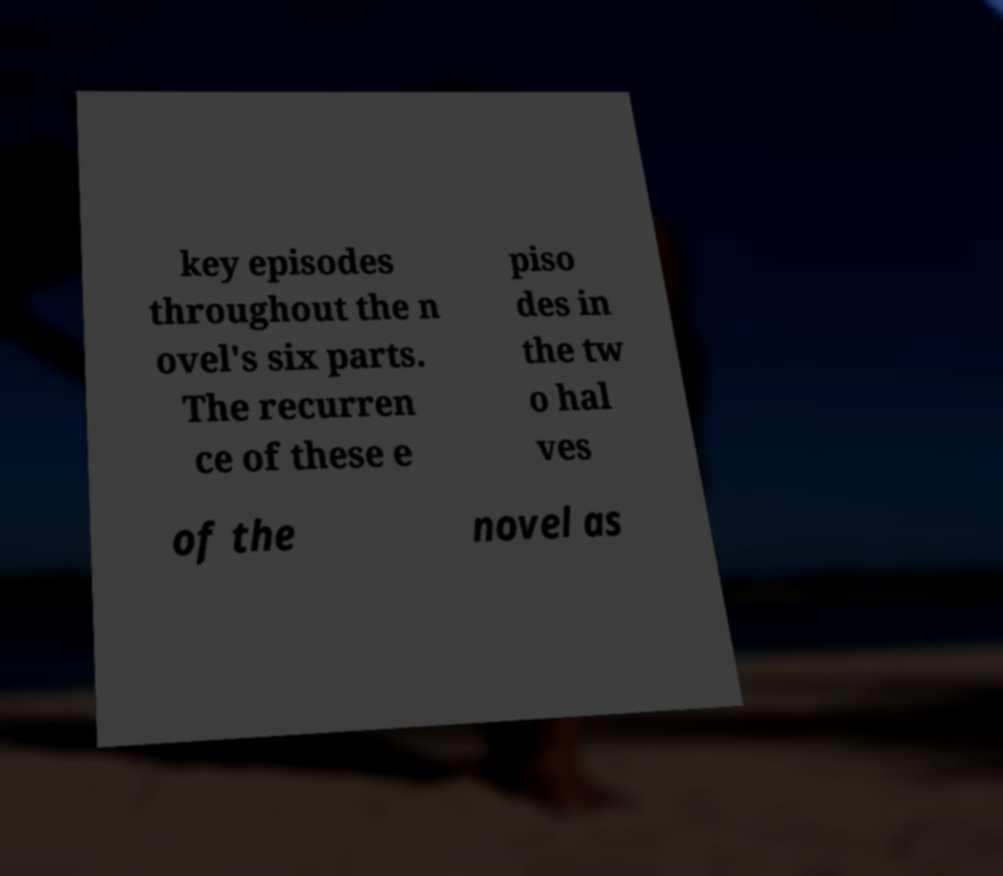Can you accurately transcribe the text from the provided image for me? key episodes throughout the n ovel's six parts. The recurren ce of these e piso des in the tw o hal ves of the novel as 